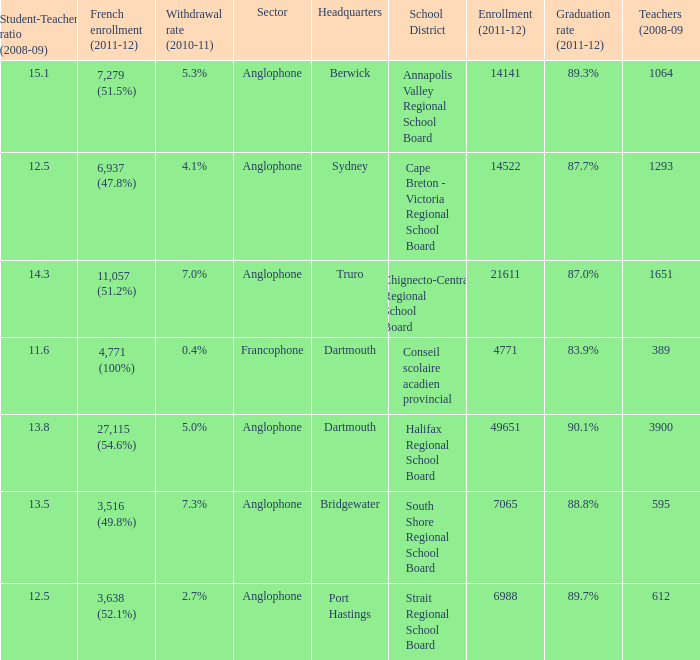What is the withdrawal rate for the school district with a graduation rate of 89.3%? 5.3%. 